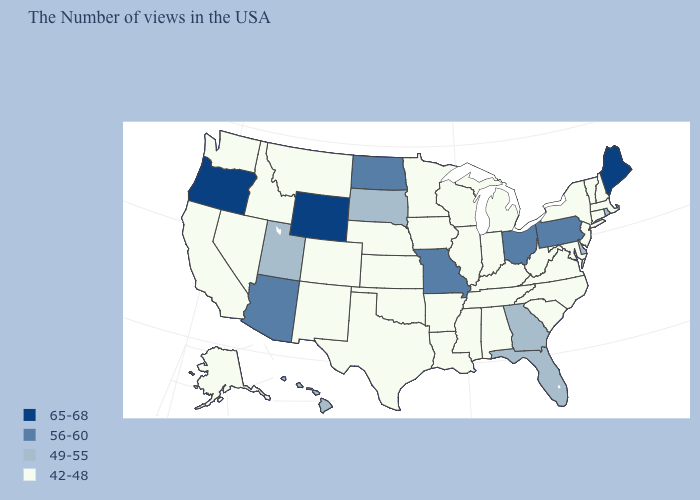Does Alaska have the lowest value in the West?
Be succinct. Yes. Which states have the highest value in the USA?
Answer briefly. Maine, Wyoming, Oregon. What is the value of Mississippi?
Concise answer only. 42-48. What is the value of West Virginia?
Quick response, please. 42-48. What is the lowest value in the West?
Give a very brief answer. 42-48. Name the states that have a value in the range 56-60?
Short answer required. Pennsylvania, Ohio, Missouri, North Dakota, Arizona. Which states hav the highest value in the Northeast?
Be succinct. Maine. Which states have the lowest value in the Northeast?
Quick response, please. Massachusetts, New Hampshire, Vermont, Connecticut, New York, New Jersey. What is the value of South Carolina?
Keep it brief. 42-48. Does California have the lowest value in the USA?
Write a very short answer. Yes. Does Kansas have the highest value in the USA?
Concise answer only. No. What is the value of California?
Keep it brief. 42-48. What is the value of Massachusetts?
Be succinct. 42-48. What is the value of Florida?
Concise answer only. 49-55. Does Georgia have the lowest value in the USA?
Concise answer only. No. 